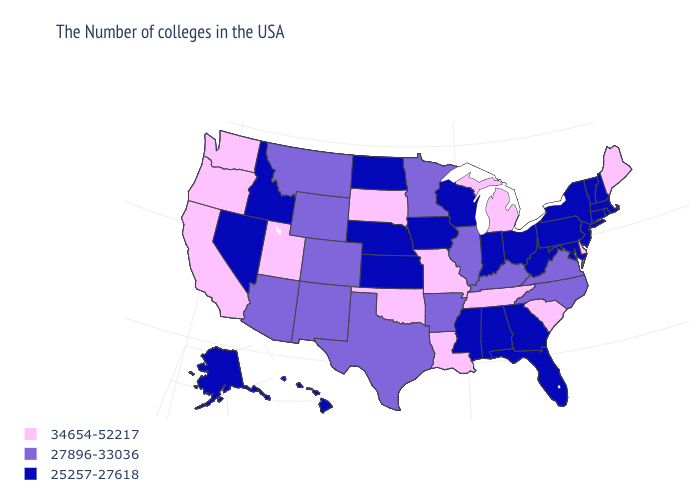What is the value of Minnesota?
Write a very short answer. 27896-33036. What is the value of North Dakota?
Quick response, please. 25257-27618. Does Michigan have a lower value than California?
Be succinct. No. How many symbols are there in the legend?
Short answer required. 3. What is the lowest value in the USA?
Be succinct. 25257-27618. Among the states that border Louisiana , does Arkansas have the highest value?
Be succinct. Yes. Name the states that have a value in the range 27896-33036?
Short answer required. Virginia, North Carolina, Kentucky, Illinois, Arkansas, Minnesota, Texas, Wyoming, Colorado, New Mexico, Montana, Arizona. Name the states that have a value in the range 25257-27618?
Short answer required. Massachusetts, Rhode Island, New Hampshire, Vermont, Connecticut, New York, New Jersey, Maryland, Pennsylvania, West Virginia, Ohio, Florida, Georgia, Indiana, Alabama, Wisconsin, Mississippi, Iowa, Kansas, Nebraska, North Dakota, Idaho, Nevada, Alaska, Hawaii. Name the states that have a value in the range 34654-52217?
Answer briefly. Maine, Delaware, South Carolina, Michigan, Tennessee, Louisiana, Missouri, Oklahoma, South Dakota, Utah, California, Washington, Oregon. What is the value of Mississippi?
Be succinct. 25257-27618. Name the states that have a value in the range 25257-27618?
Be succinct. Massachusetts, Rhode Island, New Hampshire, Vermont, Connecticut, New York, New Jersey, Maryland, Pennsylvania, West Virginia, Ohio, Florida, Georgia, Indiana, Alabama, Wisconsin, Mississippi, Iowa, Kansas, Nebraska, North Dakota, Idaho, Nevada, Alaska, Hawaii. What is the value of Montana?
Short answer required. 27896-33036. What is the value of Maryland?
Concise answer only. 25257-27618. Among the states that border Missouri , does Arkansas have the lowest value?
Be succinct. No. What is the value of Pennsylvania?
Quick response, please. 25257-27618. 